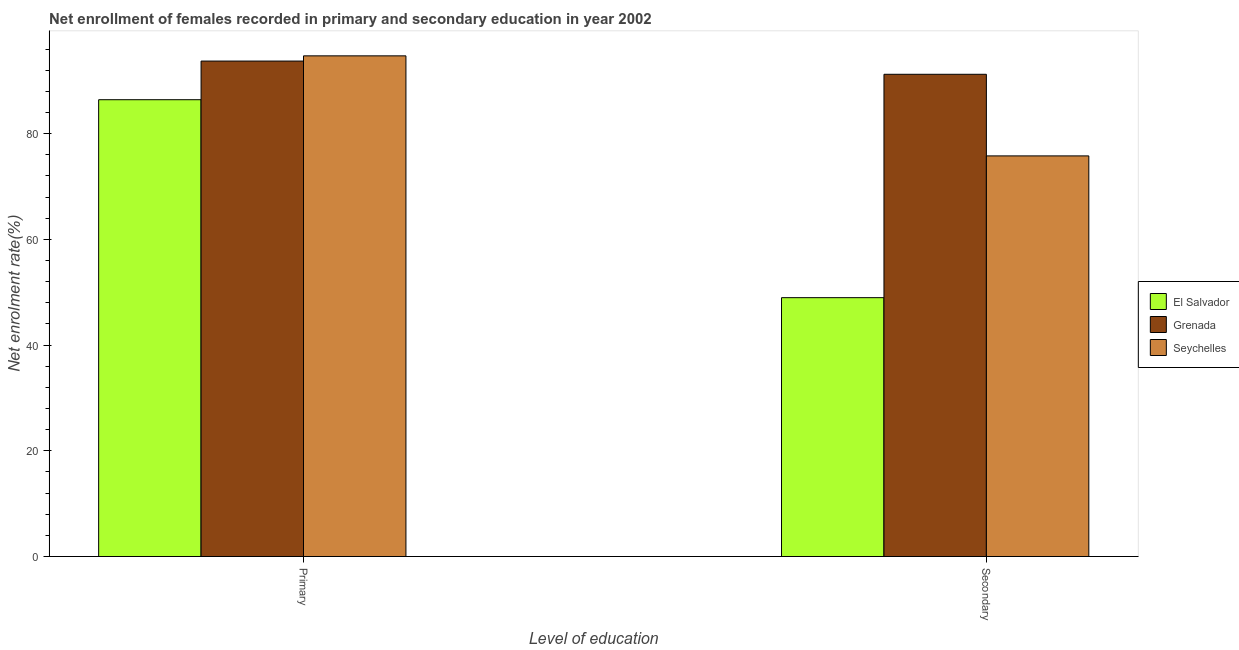How many different coloured bars are there?
Make the answer very short. 3. Are the number of bars on each tick of the X-axis equal?
Provide a short and direct response. Yes. What is the label of the 2nd group of bars from the left?
Keep it short and to the point. Secondary. What is the enrollment rate in secondary education in Grenada?
Offer a very short reply. 91.23. Across all countries, what is the maximum enrollment rate in secondary education?
Keep it short and to the point. 91.23. Across all countries, what is the minimum enrollment rate in secondary education?
Give a very brief answer. 48.98. In which country was the enrollment rate in secondary education maximum?
Offer a terse response. Grenada. In which country was the enrollment rate in secondary education minimum?
Your response must be concise. El Salvador. What is the total enrollment rate in primary education in the graph?
Offer a very short reply. 274.88. What is the difference between the enrollment rate in secondary education in Seychelles and that in Grenada?
Offer a terse response. -15.44. What is the difference between the enrollment rate in secondary education in Grenada and the enrollment rate in primary education in Seychelles?
Provide a short and direct response. -3.49. What is the average enrollment rate in secondary education per country?
Your response must be concise. 72. What is the difference between the enrollment rate in primary education and enrollment rate in secondary education in Grenada?
Your answer should be very brief. 2.5. In how many countries, is the enrollment rate in primary education greater than 88 %?
Provide a short and direct response. 2. What is the ratio of the enrollment rate in secondary education in Grenada to that in El Salvador?
Keep it short and to the point. 1.86. In how many countries, is the enrollment rate in primary education greater than the average enrollment rate in primary education taken over all countries?
Ensure brevity in your answer.  2. What does the 3rd bar from the left in Primary represents?
Ensure brevity in your answer.  Seychelles. What does the 1st bar from the right in Primary represents?
Provide a short and direct response. Seychelles. How many countries are there in the graph?
Provide a short and direct response. 3. What is the difference between two consecutive major ticks on the Y-axis?
Offer a very short reply. 20. Are the values on the major ticks of Y-axis written in scientific E-notation?
Provide a succinct answer. No. Does the graph contain grids?
Your answer should be compact. No. How many legend labels are there?
Your answer should be very brief. 3. What is the title of the graph?
Give a very brief answer. Net enrollment of females recorded in primary and secondary education in year 2002. What is the label or title of the X-axis?
Your answer should be very brief. Level of education. What is the label or title of the Y-axis?
Provide a short and direct response. Net enrolment rate(%). What is the Net enrolment rate(%) in El Salvador in Primary?
Give a very brief answer. 86.43. What is the Net enrolment rate(%) of Grenada in Primary?
Your answer should be compact. 93.74. What is the Net enrolment rate(%) in Seychelles in Primary?
Your answer should be very brief. 94.72. What is the Net enrolment rate(%) in El Salvador in Secondary?
Make the answer very short. 48.98. What is the Net enrolment rate(%) of Grenada in Secondary?
Offer a very short reply. 91.23. What is the Net enrolment rate(%) in Seychelles in Secondary?
Offer a terse response. 75.79. Across all Level of education, what is the maximum Net enrolment rate(%) in El Salvador?
Provide a short and direct response. 86.43. Across all Level of education, what is the maximum Net enrolment rate(%) of Grenada?
Make the answer very short. 93.74. Across all Level of education, what is the maximum Net enrolment rate(%) in Seychelles?
Your answer should be very brief. 94.72. Across all Level of education, what is the minimum Net enrolment rate(%) of El Salvador?
Give a very brief answer. 48.98. Across all Level of education, what is the minimum Net enrolment rate(%) in Grenada?
Provide a short and direct response. 91.23. Across all Level of education, what is the minimum Net enrolment rate(%) of Seychelles?
Offer a very short reply. 75.79. What is the total Net enrolment rate(%) of El Salvador in the graph?
Make the answer very short. 135.4. What is the total Net enrolment rate(%) in Grenada in the graph?
Give a very brief answer. 184.97. What is the total Net enrolment rate(%) of Seychelles in the graph?
Keep it short and to the point. 170.52. What is the difference between the Net enrolment rate(%) in El Salvador in Primary and that in Secondary?
Your answer should be compact. 37.45. What is the difference between the Net enrolment rate(%) in Grenada in Primary and that in Secondary?
Offer a very short reply. 2.5. What is the difference between the Net enrolment rate(%) in Seychelles in Primary and that in Secondary?
Ensure brevity in your answer.  18.93. What is the difference between the Net enrolment rate(%) of El Salvador in Primary and the Net enrolment rate(%) of Grenada in Secondary?
Make the answer very short. -4.81. What is the difference between the Net enrolment rate(%) in El Salvador in Primary and the Net enrolment rate(%) in Seychelles in Secondary?
Provide a succinct answer. 10.63. What is the difference between the Net enrolment rate(%) of Grenada in Primary and the Net enrolment rate(%) of Seychelles in Secondary?
Offer a terse response. 17.94. What is the average Net enrolment rate(%) in El Salvador per Level of education?
Give a very brief answer. 67.7. What is the average Net enrolment rate(%) of Grenada per Level of education?
Give a very brief answer. 92.49. What is the average Net enrolment rate(%) of Seychelles per Level of education?
Make the answer very short. 85.26. What is the difference between the Net enrolment rate(%) in El Salvador and Net enrolment rate(%) in Grenada in Primary?
Your response must be concise. -7.31. What is the difference between the Net enrolment rate(%) of El Salvador and Net enrolment rate(%) of Seychelles in Primary?
Make the answer very short. -8.3. What is the difference between the Net enrolment rate(%) of Grenada and Net enrolment rate(%) of Seychelles in Primary?
Make the answer very short. -0.99. What is the difference between the Net enrolment rate(%) of El Salvador and Net enrolment rate(%) of Grenada in Secondary?
Offer a terse response. -42.26. What is the difference between the Net enrolment rate(%) in El Salvador and Net enrolment rate(%) in Seychelles in Secondary?
Your answer should be compact. -26.82. What is the difference between the Net enrolment rate(%) in Grenada and Net enrolment rate(%) in Seychelles in Secondary?
Make the answer very short. 15.44. What is the ratio of the Net enrolment rate(%) in El Salvador in Primary to that in Secondary?
Offer a terse response. 1.76. What is the ratio of the Net enrolment rate(%) of Grenada in Primary to that in Secondary?
Provide a succinct answer. 1.03. What is the ratio of the Net enrolment rate(%) of Seychelles in Primary to that in Secondary?
Offer a very short reply. 1.25. What is the difference between the highest and the second highest Net enrolment rate(%) in El Salvador?
Ensure brevity in your answer.  37.45. What is the difference between the highest and the second highest Net enrolment rate(%) in Grenada?
Provide a short and direct response. 2.5. What is the difference between the highest and the second highest Net enrolment rate(%) in Seychelles?
Your answer should be very brief. 18.93. What is the difference between the highest and the lowest Net enrolment rate(%) of El Salvador?
Offer a very short reply. 37.45. What is the difference between the highest and the lowest Net enrolment rate(%) in Grenada?
Make the answer very short. 2.5. What is the difference between the highest and the lowest Net enrolment rate(%) of Seychelles?
Your response must be concise. 18.93. 